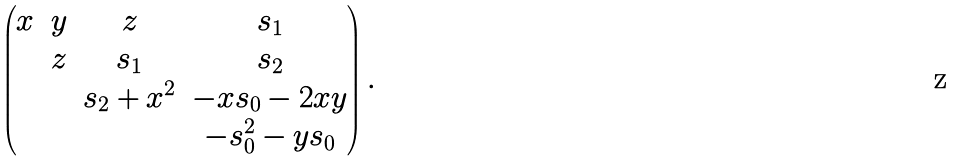Convert formula to latex. <formula><loc_0><loc_0><loc_500><loc_500>\begin{pmatrix} x & y & z & s _ { 1 } \\ & z & s _ { 1 } & s _ { 2 } \\ & & s _ { 2 } + x ^ { 2 } & - x s _ { 0 } - 2 x y \\ & & & - s _ { 0 } ^ { 2 } - y s _ { 0 } \end{pmatrix} .</formula> 